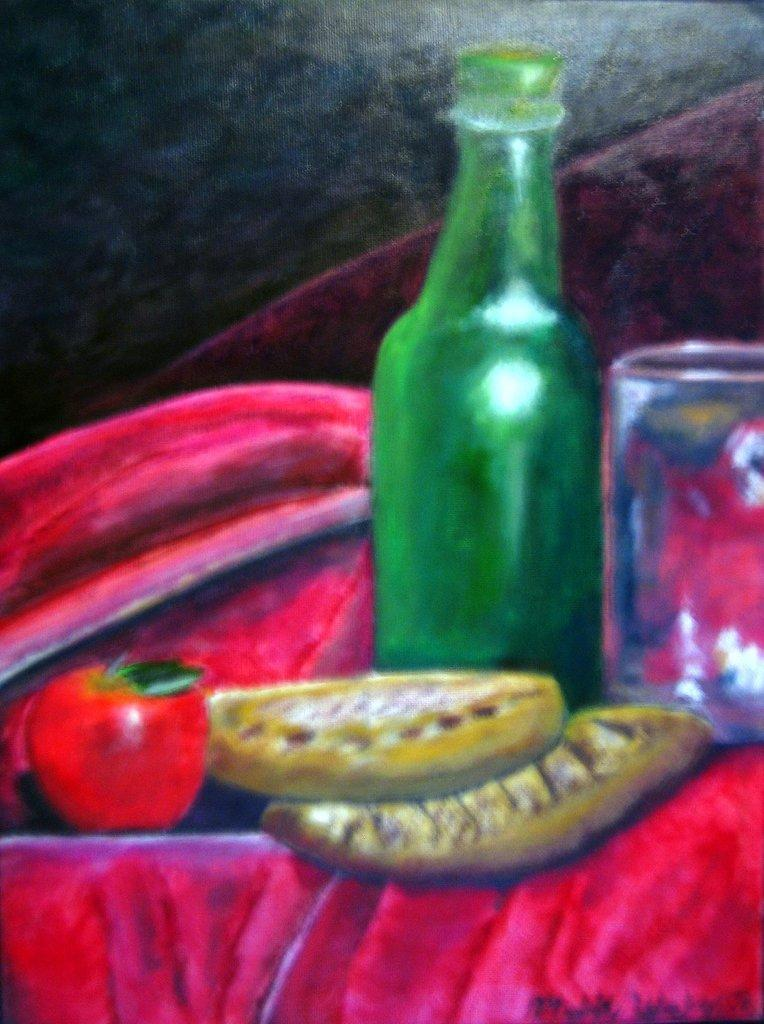What is the main subject of the image? The image contains a painting. What is depicted in the painting? The painting depicts glass, a bottle, and fruit. Are there any other objects in the painting? Yes, the painting includes other objects. How would you describe the background of the image? The background of the image is blurry. How many baseballs are visible in the painting? There are no baseballs depicted in the painting; it features glass, a bottle, fruit, and other objects. What type of knowledge can be gained from the cars in the painting? There are no cars present in the painting, so no knowledge can be gained from them. 